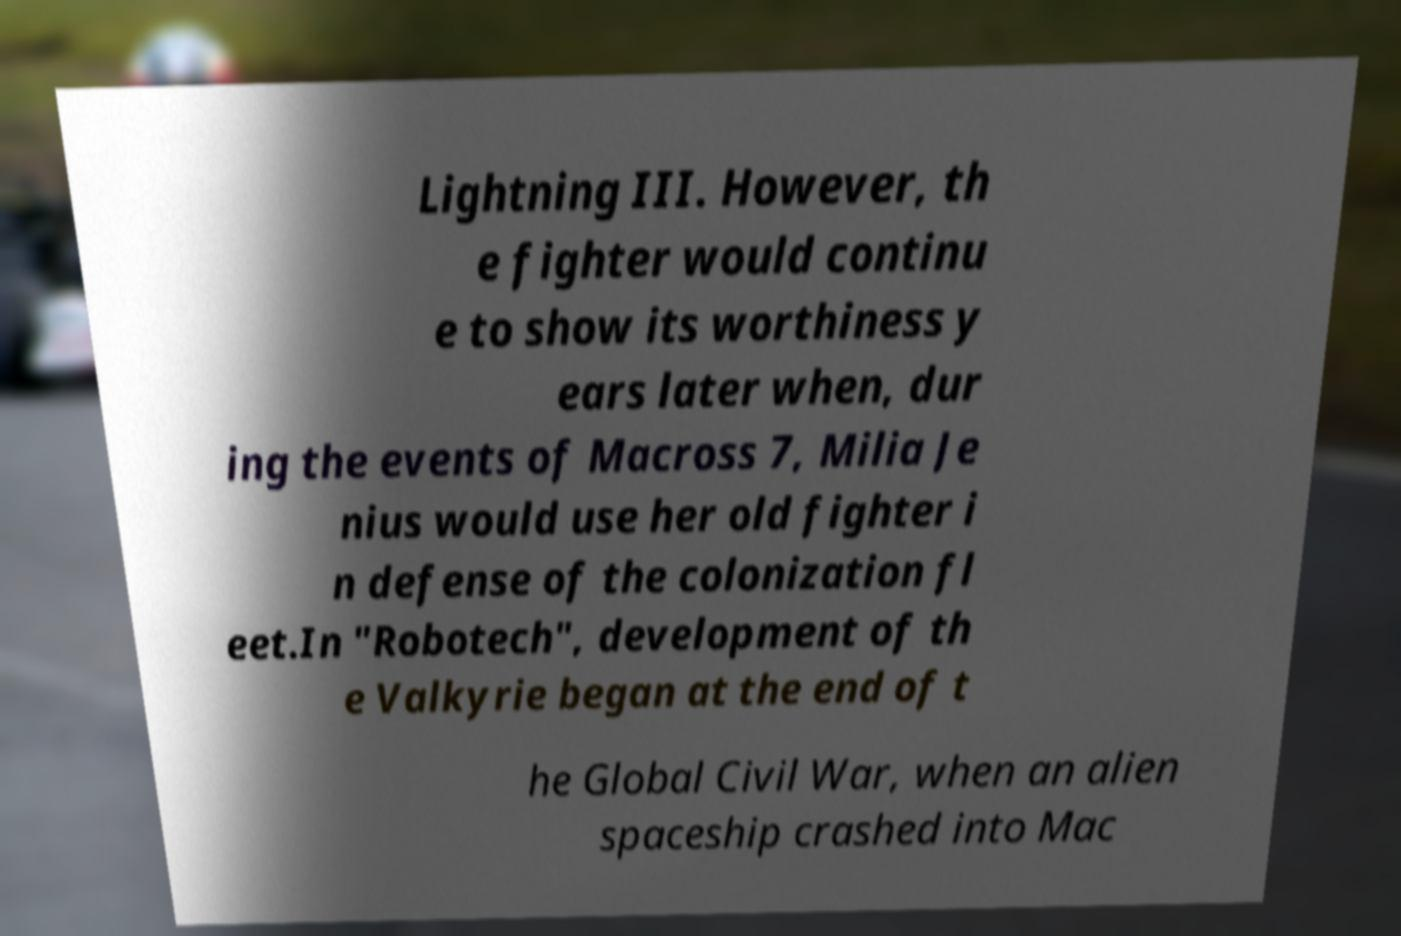Please read and relay the text visible in this image. What does it say? Lightning III. However, th e fighter would continu e to show its worthiness y ears later when, dur ing the events of Macross 7, Milia Je nius would use her old fighter i n defense of the colonization fl eet.In "Robotech", development of th e Valkyrie began at the end of t he Global Civil War, when an alien spaceship crashed into Mac 